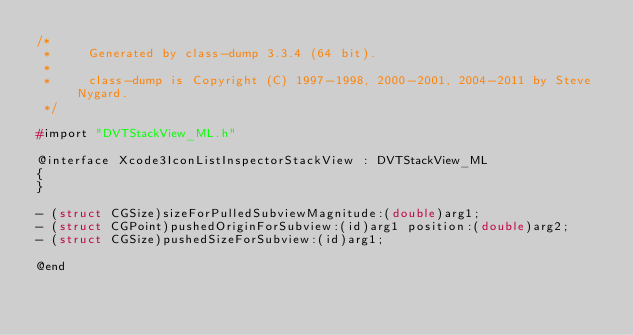<code> <loc_0><loc_0><loc_500><loc_500><_C_>/*
 *     Generated by class-dump 3.3.4 (64 bit).
 *
 *     class-dump is Copyright (C) 1997-1998, 2000-2001, 2004-2011 by Steve Nygard.
 */

#import "DVTStackView_ML.h"

@interface Xcode3IconListInspectorStackView : DVTStackView_ML
{
}

- (struct CGSize)sizeForPulledSubviewMagnitude:(double)arg1;
- (struct CGPoint)pushedOriginForSubview:(id)arg1 position:(double)arg2;
- (struct CGSize)pushedSizeForSubview:(id)arg1;

@end

</code> 